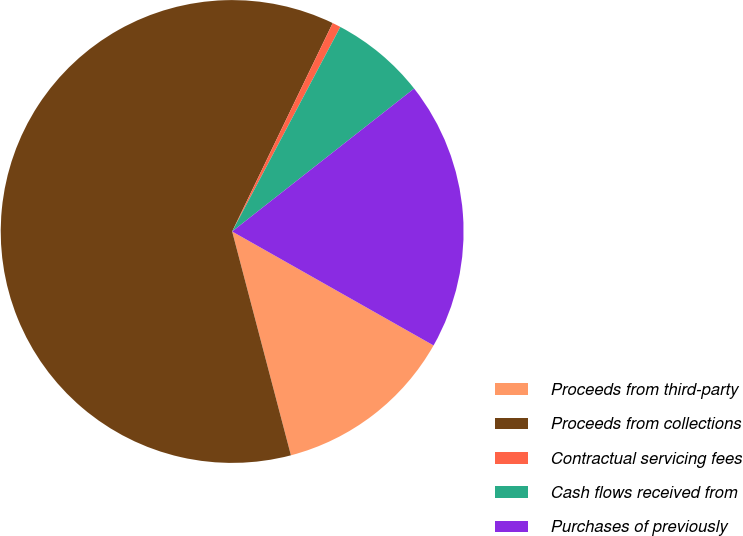Convert chart. <chart><loc_0><loc_0><loc_500><loc_500><pie_chart><fcel>Proceeds from third-party<fcel>Proceeds from collections<fcel>Contractual servicing fees<fcel>Cash flows received from<fcel>Purchases of previously<nl><fcel>12.72%<fcel>61.24%<fcel>0.59%<fcel>6.66%<fcel>18.79%<nl></chart> 